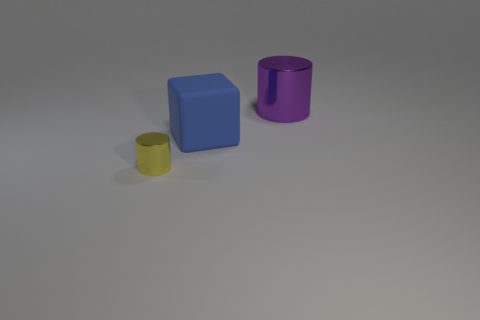How big is the cube?
Make the answer very short. Large. The cylinder that is the same size as the cube is what color?
Your response must be concise. Purple. What is the material of the blue thing?
Your answer should be very brief. Rubber. How many red things are there?
Give a very brief answer. 0. What number of other objects are the same size as the block?
Offer a terse response. 1. The metallic cylinder behind the tiny metallic object is what color?
Give a very brief answer. Purple. Is the material of the cylinder on the right side of the yellow object the same as the small yellow cylinder?
Your response must be concise. Yes. What number of things are both in front of the purple cylinder and to the right of the tiny yellow shiny cylinder?
Make the answer very short. 1. There is a cylinder in front of the shiny cylinder that is behind the metal cylinder to the left of the big purple metallic cylinder; what is its color?
Offer a very short reply. Yellow. What number of other things are the same shape as the big blue object?
Offer a terse response. 0. 